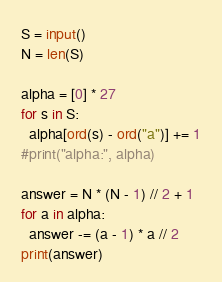<code> <loc_0><loc_0><loc_500><loc_500><_Python_>S = input()
N = len(S)

alpha = [0] * 27
for s in S:
  alpha[ord(s) - ord("a")] += 1
#print("alpha:", alpha)

answer = N * (N - 1) // 2 + 1
for a in alpha:
  answer -= (a - 1) * a // 2
print(answer)</code> 